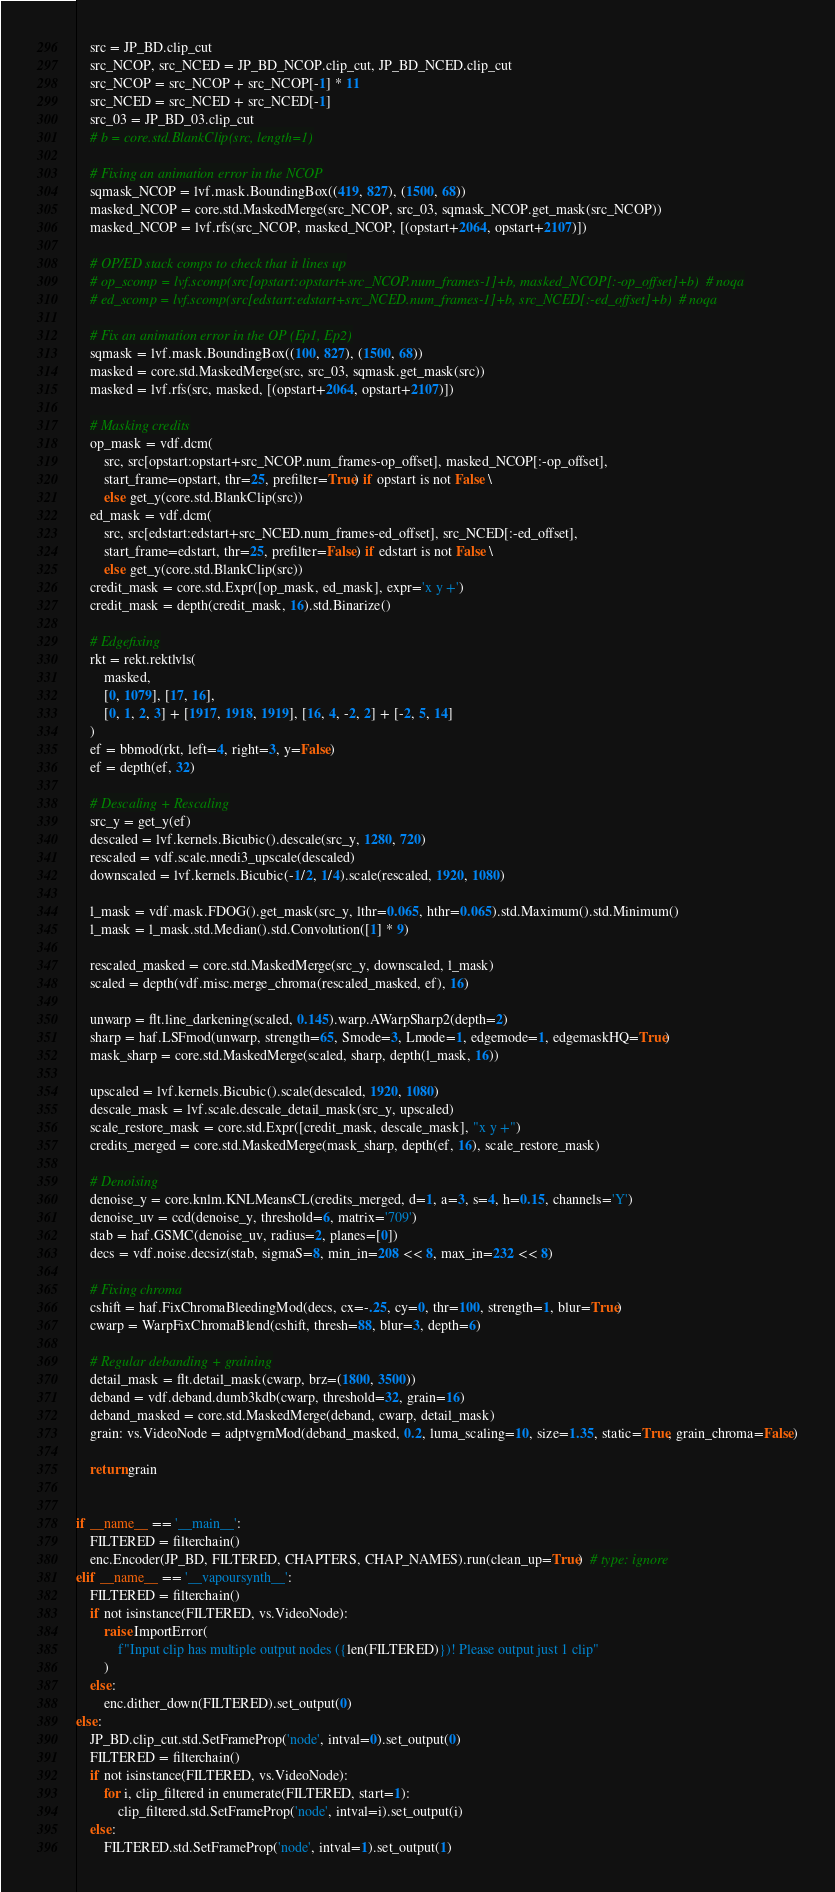<code> <loc_0><loc_0><loc_500><loc_500><_Python_>
    src = JP_BD.clip_cut
    src_NCOP, src_NCED = JP_BD_NCOP.clip_cut, JP_BD_NCED.clip_cut
    src_NCOP = src_NCOP + src_NCOP[-1] * 11
    src_NCED = src_NCED + src_NCED[-1]
    src_03 = JP_BD_03.clip_cut
    # b = core.std.BlankClip(src, length=1)

    # Fixing an animation error in the NCOP
    sqmask_NCOP = lvf.mask.BoundingBox((419, 827), (1500, 68))
    masked_NCOP = core.std.MaskedMerge(src_NCOP, src_03, sqmask_NCOP.get_mask(src_NCOP))
    masked_NCOP = lvf.rfs(src_NCOP, masked_NCOP, [(opstart+2064, opstart+2107)])

    # OP/ED stack comps to check that it lines up
    # op_scomp = lvf.scomp(src[opstart:opstart+src_NCOP.num_frames-1]+b, masked_NCOP[:-op_offset]+b)  # noqa
    # ed_scomp = lvf.scomp(src[edstart:edstart+src_NCED.num_frames-1]+b, src_NCED[:-ed_offset]+b)  # noqa

    # Fix an animation error in the OP (Ep1, Ep2)
    sqmask = lvf.mask.BoundingBox((100, 827), (1500, 68))
    masked = core.std.MaskedMerge(src, src_03, sqmask.get_mask(src))
    masked = lvf.rfs(src, masked, [(opstart+2064, opstart+2107)])

    # Masking credits
    op_mask = vdf.dcm(
        src, src[opstart:opstart+src_NCOP.num_frames-op_offset], masked_NCOP[:-op_offset],
        start_frame=opstart, thr=25, prefilter=True) if opstart is not False \
        else get_y(core.std.BlankClip(src))
    ed_mask = vdf.dcm(
        src, src[edstart:edstart+src_NCED.num_frames-ed_offset], src_NCED[:-ed_offset],
        start_frame=edstart, thr=25, prefilter=False) if edstart is not False \
        else get_y(core.std.BlankClip(src))
    credit_mask = core.std.Expr([op_mask, ed_mask], expr='x y +')
    credit_mask = depth(credit_mask, 16).std.Binarize()

    # Edgefixing
    rkt = rekt.rektlvls(
        masked,
        [0, 1079], [17, 16],
        [0, 1, 2, 3] + [1917, 1918, 1919], [16, 4, -2, 2] + [-2, 5, 14]
    )
    ef = bbmod(rkt, left=4, right=3, y=False)
    ef = depth(ef, 32)

    # Descaling + Rescaling
    src_y = get_y(ef)
    descaled = lvf.kernels.Bicubic().descale(src_y, 1280, 720)
    rescaled = vdf.scale.nnedi3_upscale(descaled)
    downscaled = lvf.kernels.Bicubic(-1/2, 1/4).scale(rescaled, 1920, 1080)

    l_mask = vdf.mask.FDOG().get_mask(src_y, lthr=0.065, hthr=0.065).std.Maximum().std.Minimum()
    l_mask = l_mask.std.Median().std.Convolution([1] * 9)

    rescaled_masked = core.std.MaskedMerge(src_y, downscaled, l_mask)
    scaled = depth(vdf.misc.merge_chroma(rescaled_masked, ef), 16)

    unwarp = flt.line_darkening(scaled, 0.145).warp.AWarpSharp2(depth=2)
    sharp = haf.LSFmod(unwarp, strength=65, Smode=3, Lmode=1, edgemode=1, edgemaskHQ=True)
    mask_sharp = core.std.MaskedMerge(scaled, sharp, depth(l_mask, 16))

    upscaled = lvf.kernels.Bicubic().scale(descaled, 1920, 1080)
    descale_mask = lvf.scale.descale_detail_mask(src_y, upscaled)
    scale_restore_mask = core.std.Expr([credit_mask, descale_mask], "x y +")
    credits_merged = core.std.MaskedMerge(mask_sharp, depth(ef, 16), scale_restore_mask)

    # Denoising
    denoise_y = core.knlm.KNLMeansCL(credits_merged, d=1, a=3, s=4, h=0.15, channels='Y')
    denoise_uv = ccd(denoise_y, threshold=6, matrix='709')
    stab = haf.GSMC(denoise_uv, radius=2, planes=[0])
    decs = vdf.noise.decsiz(stab, sigmaS=8, min_in=208 << 8, max_in=232 << 8)

    # Fixing chroma
    cshift = haf.FixChromaBleedingMod(decs, cx=-.25, cy=0, thr=100, strength=1, blur=True)
    cwarp = WarpFixChromaBlend(cshift, thresh=88, blur=3, depth=6)

    # Regular debanding + graining
    detail_mask = flt.detail_mask(cwarp, brz=(1800, 3500))
    deband = vdf.deband.dumb3kdb(cwarp, threshold=32, grain=16)
    deband_masked = core.std.MaskedMerge(deband, cwarp, detail_mask)
    grain: vs.VideoNode = adptvgrnMod(deband_masked, 0.2, luma_scaling=10, size=1.35, static=True, grain_chroma=False)

    return grain


if __name__ == '__main__':
    FILTERED = filterchain()
    enc.Encoder(JP_BD, FILTERED, CHAPTERS, CHAP_NAMES).run(clean_up=True)  # type: ignore
elif __name__ == '__vapoursynth__':
    FILTERED = filterchain()
    if not isinstance(FILTERED, vs.VideoNode):
        raise ImportError(
            f"Input clip has multiple output nodes ({len(FILTERED)})! Please output just 1 clip"
        )
    else:
        enc.dither_down(FILTERED).set_output(0)
else:
    JP_BD.clip_cut.std.SetFrameProp('node', intval=0).set_output(0)
    FILTERED = filterchain()
    if not isinstance(FILTERED, vs.VideoNode):
        for i, clip_filtered in enumerate(FILTERED, start=1):
            clip_filtered.std.SetFrameProp('node', intval=i).set_output(i)
    else:
        FILTERED.std.SetFrameProp('node', intval=1).set_output(1)
</code> 